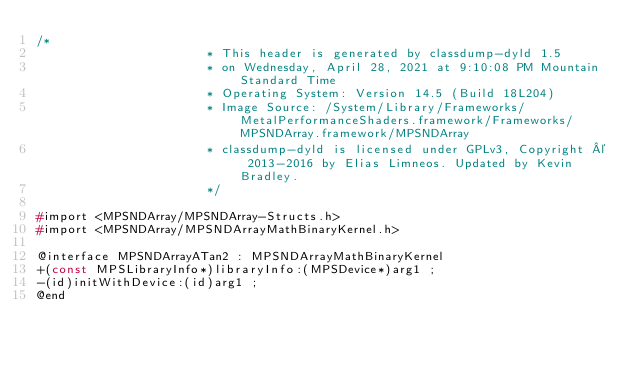Convert code to text. <code><loc_0><loc_0><loc_500><loc_500><_C_>/*
                       * This header is generated by classdump-dyld 1.5
                       * on Wednesday, April 28, 2021 at 9:10:08 PM Mountain Standard Time
                       * Operating System: Version 14.5 (Build 18L204)
                       * Image Source: /System/Library/Frameworks/MetalPerformanceShaders.framework/Frameworks/MPSNDArray.framework/MPSNDArray
                       * classdump-dyld is licensed under GPLv3, Copyright © 2013-2016 by Elias Limneos. Updated by Kevin Bradley.
                       */

#import <MPSNDArray/MPSNDArray-Structs.h>
#import <MPSNDArray/MPSNDArrayMathBinaryKernel.h>

@interface MPSNDArrayATan2 : MPSNDArrayMathBinaryKernel
+(const MPSLibraryInfo*)libraryInfo:(MPSDevice*)arg1 ;
-(id)initWithDevice:(id)arg1 ;
@end

</code> 